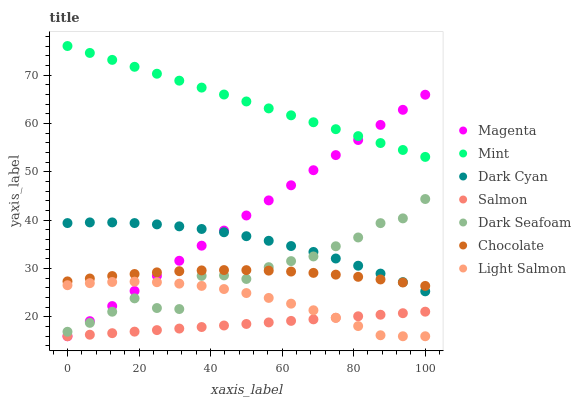Does Salmon have the minimum area under the curve?
Answer yes or no. Yes. Does Mint have the maximum area under the curve?
Answer yes or no. Yes. Does Chocolate have the minimum area under the curve?
Answer yes or no. No. Does Chocolate have the maximum area under the curve?
Answer yes or no. No. Is Magenta the smoothest?
Answer yes or no. Yes. Is Dark Seafoam the roughest?
Answer yes or no. Yes. Is Salmon the smoothest?
Answer yes or no. No. Is Salmon the roughest?
Answer yes or no. No. Does Light Salmon have the lowest value?
Answer yes or no. Yes. Does Chocolate have the lowest value?
Answer yes or no. No. Does Mint have the highest value?
Answer yes or no. Yes. Does Chocolate have the highest value?
Answer yes or no. No. Is Light Salmon less than Dark Cyan?
Answer yes or no. Yes. Is Mint greater than Chocolate?
Answer yes or no. Yes. Does Mint intersect Magenta?
Answer yes or no. Yes. Is Mint less than Magenta?
Answer yes or no. No. Is Mint greater than Magenta?
Answer yes or no. No. Does Light Salmon intersect Dark Cyan?
Answer yes or no. No. 